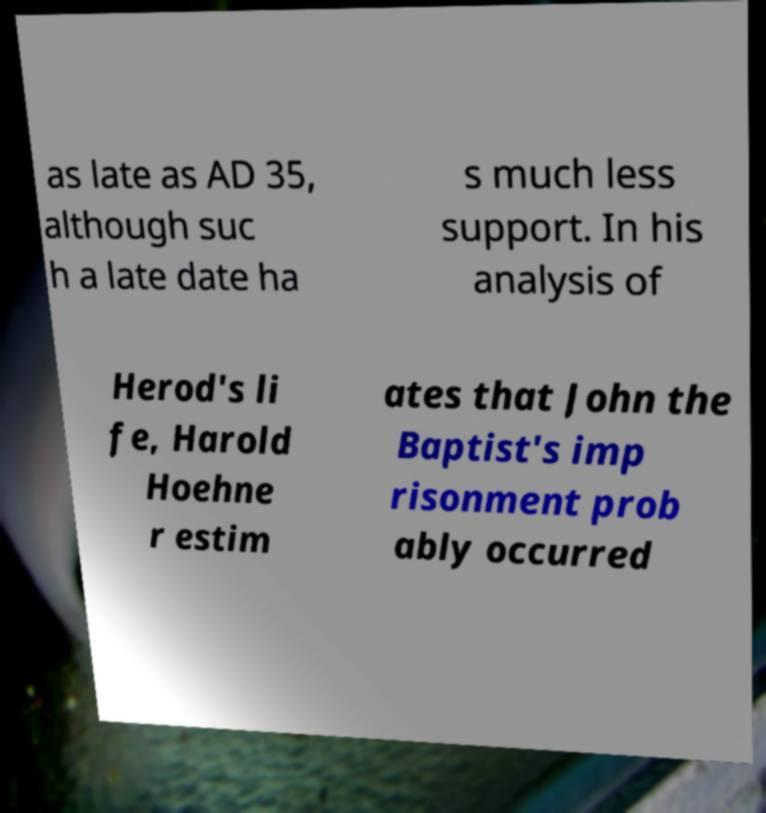Could you extract and type out the text from this image? as late as AD 35, although suc h a late date ha s much less support. In his analysis of Herod's li fe, Harold Hoehne r estim ates that John the Baptist's imp risonment prob ably occurred 